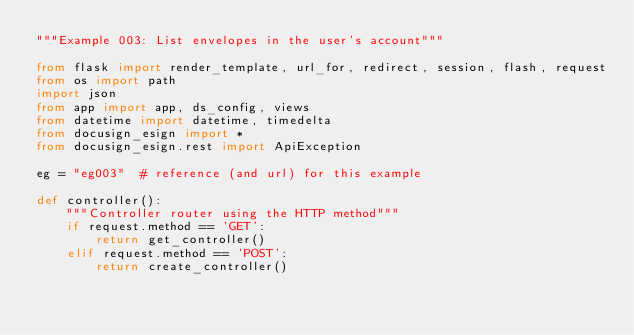Convert code to text. <code><loc_0><loc_0><loc_500><loc_500><_Python_>"""Example 003: List envelopes in the user's account"""

from flask import render_template, url_for, redirect, session, flash, request
from os import path
import json
from app import app, ds_config, views
from datetime import datetime, timedelta
from docusign_esign import *
from docusign_esign.rest import ApiException

eg = "eg003"  # reference (and url) for this example

def controller():
    """Controller router using the HTTP method"""
    if request.method == 'GET':
        return get_controller()
    elif request.method == 'POST':
        return create_controller()</code> 